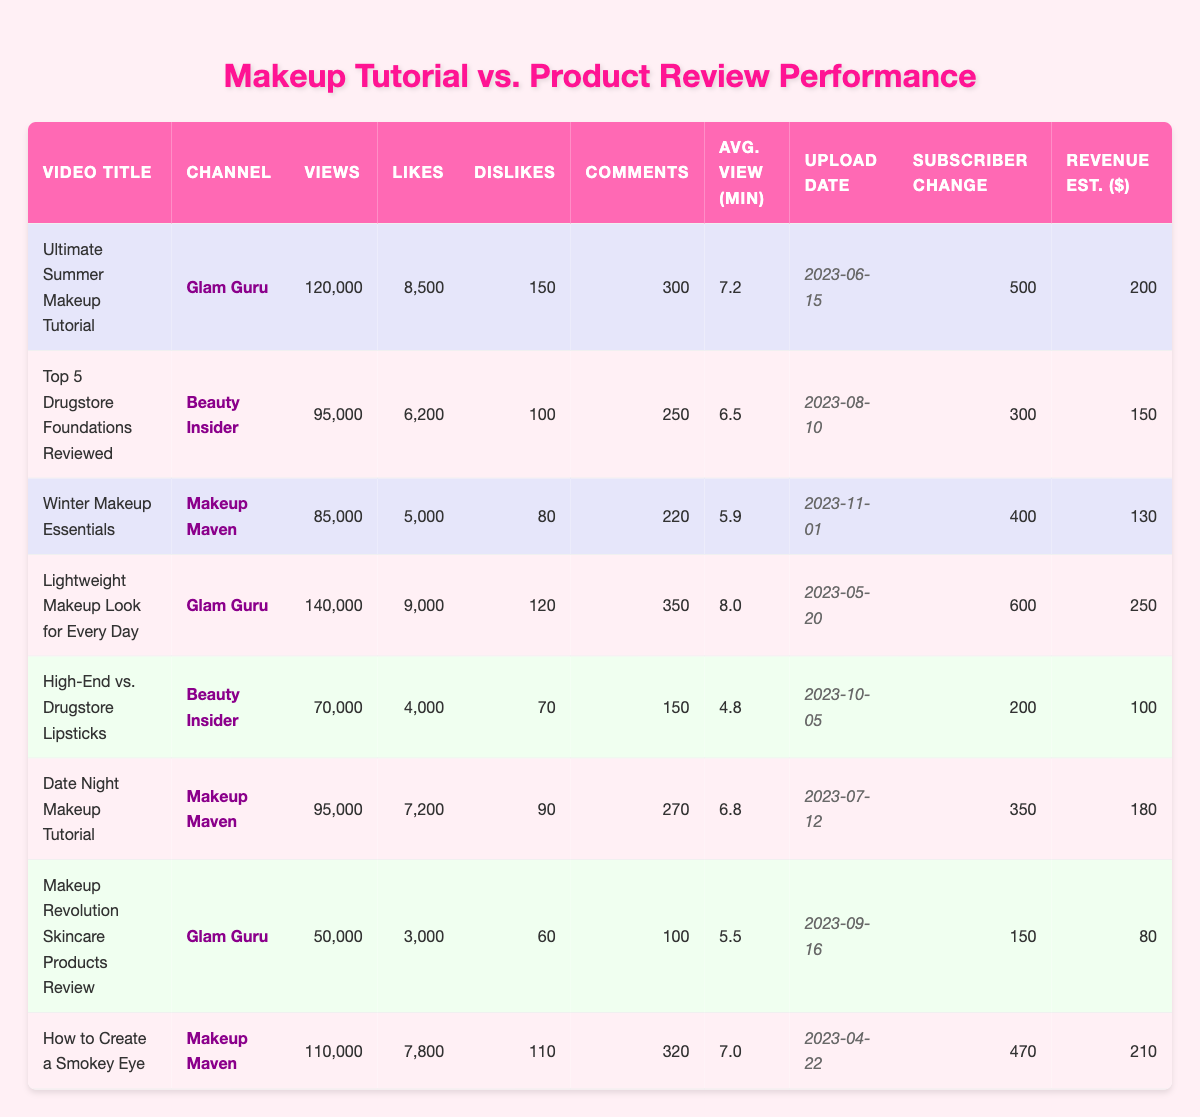What is the total number of views for all tutorials? To find the total views of tutorials, we add the views of each tutorial: 120000 + 85000 + 140000 + 95000 + 110000 = 500000.
Answer: 500000 Which video received the highest number of likes? The likes for each video are compared: 8500, 6200, 5000, 9000, 4000, 7200, 3000, 7800. The highest number is 9000 for "Lightweight Makeup Look for Every Day."
Answer: 9000 Did "Glam Guru" upload more tutorials than "Makeup Maven"? "Glam Guru" has 3 tutorials, while "Makeup Maven" has 3 tutorials as well. Therefore, both channels have uploaded an equal number of tutorials.
Answer: No What is the average view duration for product reviews? We find the average view duration for reviews: (6.5 + 4.8 + 6.8 + 5.5) / 4 = 5.4 minutes average.
Answer: 5.4 Which video had the highest revenue estimate? We check the revenue estimates: 200, 150, 130, 250, 100, 180, 80, 210. The highest is 250 for "Lightweight Makeup Look for Every Day."
Answer: 250 What is the subscriber change for the "Winter Makeup Essentials" tutorial? The subscriber change for the "Winter Makeup Essentials" tutorial is listed as 400.
Answer: 400 Which makeup tutorial had the most comments? We look at the comment counts: 300, 250, 220, 350, 270, 320. The highest is 350 for "Lightweight Makeup Look for Every Day."
Answer: 350 What is the difference in views between the most viewed tutorial and the least viewed review? The most viewed tutorial is 140000, and the least viewed review is 50000. The difference is 140000 - 50000 = 90000.
Answer: 90000 Is there a tutorial that also had a higher number of dislikes than its likes? We compare the likes and dislikes: "Makeup Revolution Skincare Products Review" had 3000 likes and 60 dislikes. No tutorial had more dislikes than likes.
Answer: No Which channel had the highest average views for their tutorials? The average views for Glam Guru's tutorials is (120000 + 140000) / 2 = 130000, and for Makeup Maven's (85000 + 95000 + 110000) / 3 = 100000. Glam Guru has higher average views.
Answer: Glam Guru 